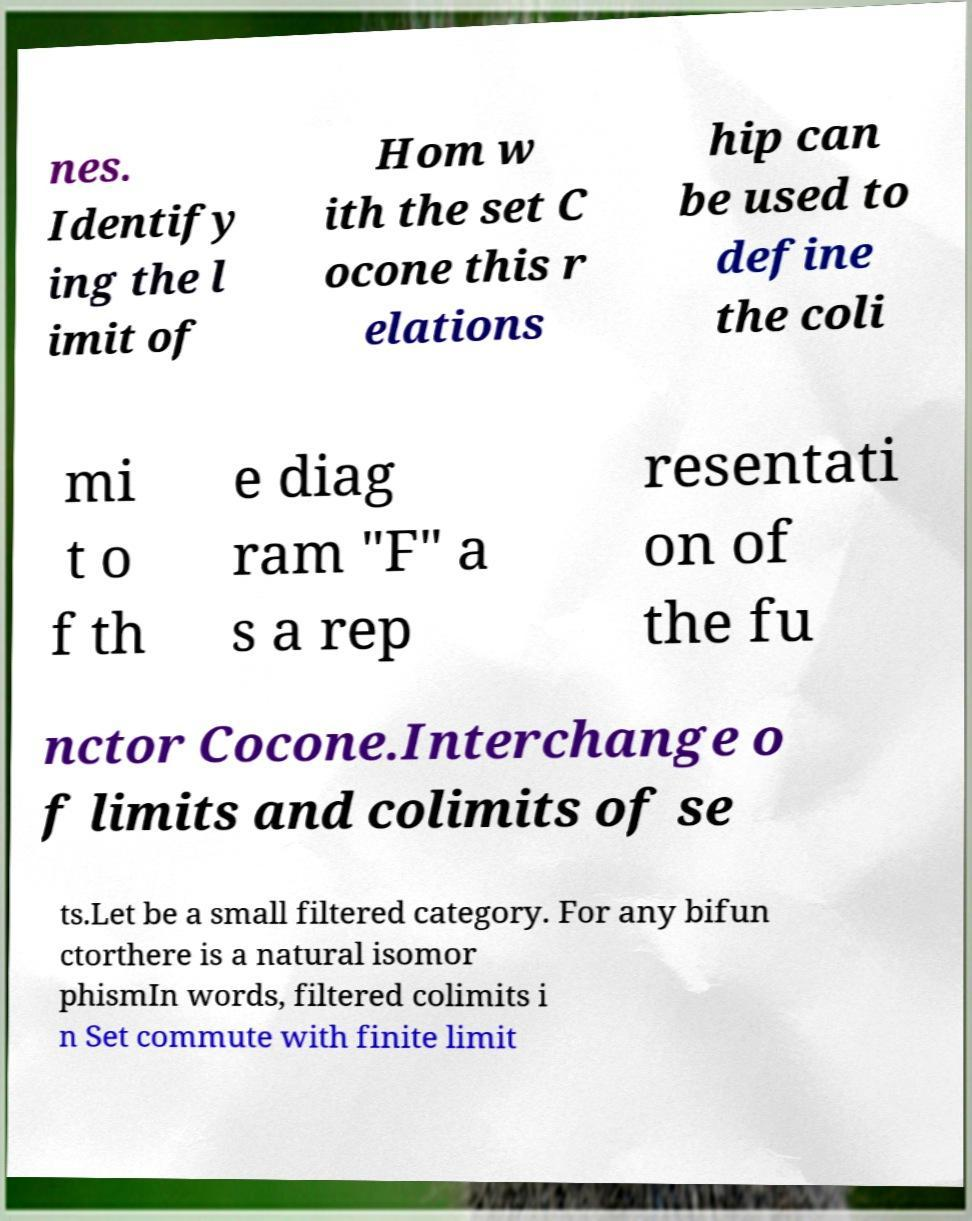Can you accurately transcribe the text from the provided image for me? nes. Identify ing the l imit of Hom w ith the set C ocone this r elations hip can be used to define the coli mi t o f th e diag ram "F" a s a rep resentati on of the fu nctor Cocone.Interchange o f limits and colimits of se ts.Let be a small filtered category. For any bifun ctorthere is a natural isomor phismIn words, filtered colimits i n Set commute with finite limit 